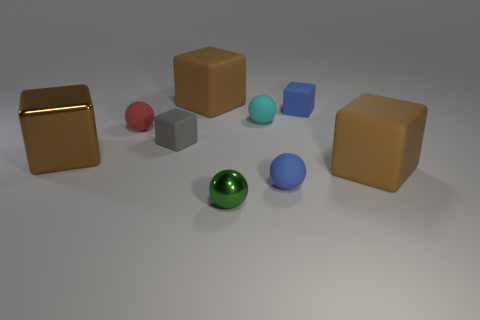Subtract all blue balls. How many balls are left? 3 Subtract all purple cylinders. How many brown blocks are left? 3 Subtract 2 blocks. How many blocks are left? 3 Subtract all red balls. How many balls are left? 3 Add 1 cyan shiny cylinders. How many objects exist? 10 Subtract all blocks. How many objects are left? 4 Subtract all small blue rubber blocks. Subtract all tiny cyan things. How many objects are left? 7 Add 9 tiny cyan matte objects. How many tiny cyan matte objects are left? 10 Add 5 tiny shiny objects. How many tiny shiny objects exist? 6 Subtract 0 red blocks. How many objects are left? 9 